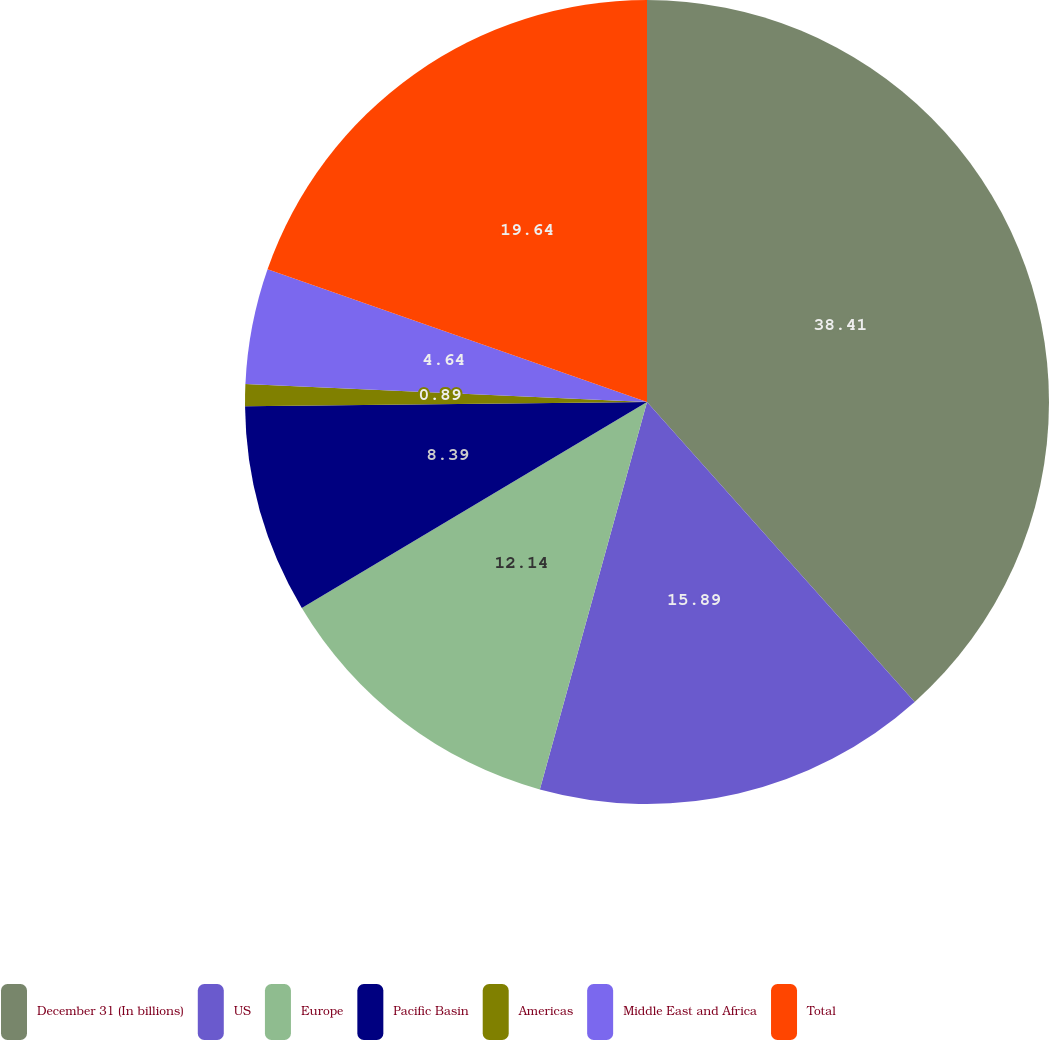Convert chart. <chart><loc_0><loc_0><loc_500><loc_500><pie_chart><fcel>December 31 (In billions)<fcel>US<fcel>Europe<fcel>Pacific Basin<fcel>Americas<fcel>Middle East and Africa<fcel>Total<nl><fcel>38.4%<fcel>15.89%<fcel>12.14%<fcel>8.39%<fcel>0.89%<fcel>4.64%<fcel>19.64%<nl></chart> 